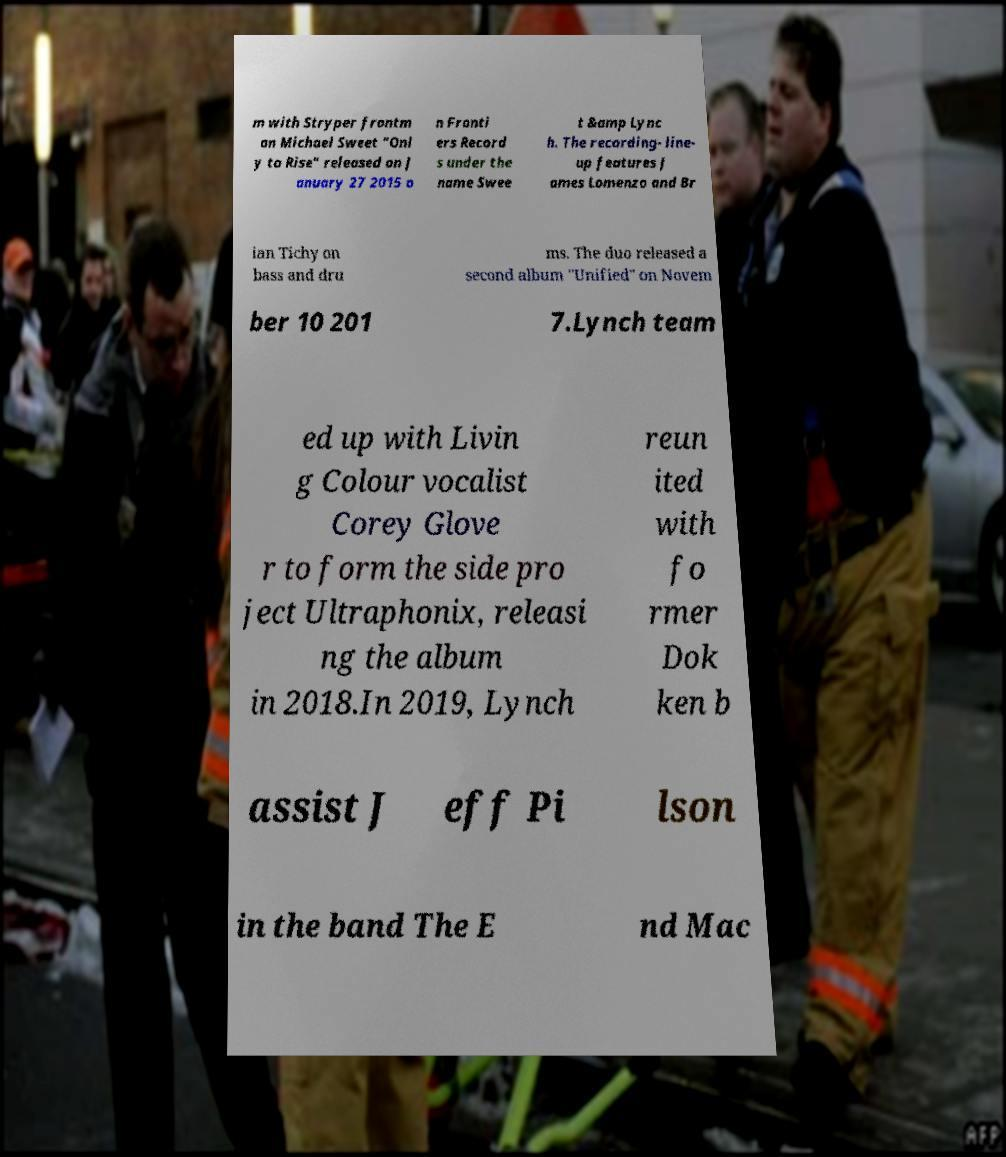I need the written content from this picture converted into text. Can you do that? m with Stryper frontm an Michael Sweet "Onl y to Rise" released on J anuary 27 2015 o n Fronti ers Record s under the name Swee t &amp Lync h. The recording- line- up features J ames Lomenzo and Br ian Tichy on bass and dru ms. The duo released a second album "Unified" on Novem ber 10 201 7.Lynch team ed up with Livin g Colour vocalist Corey Glove r to form the side pro ject Ultraphonix, releasi ng the album in 2018.In 2019, Lynch reun ited with fo rmer Dok ken b assist J eff Pi lson in the band The E nd Mac 